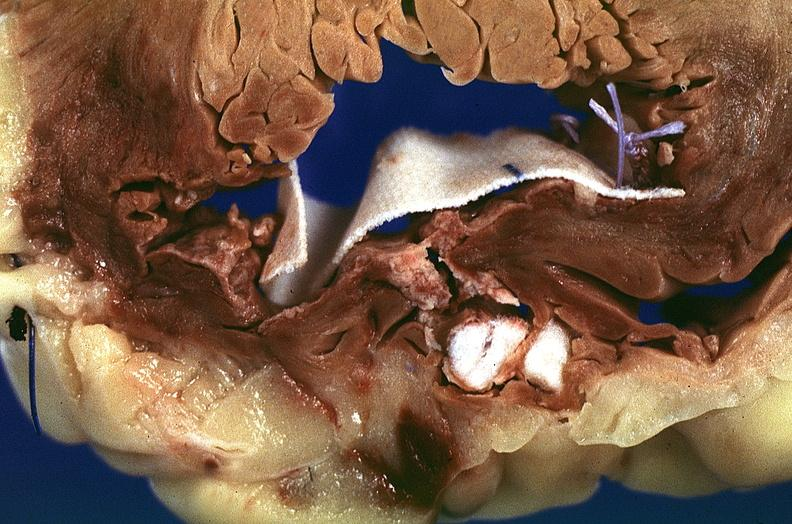s cardiovascular present?
Answer the question using a single word or phrase. Yes 